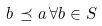<formula> <loc_0><loc_0><loc_500><loc_500>b \, \preceq a \, \forall b \in S</formula> 